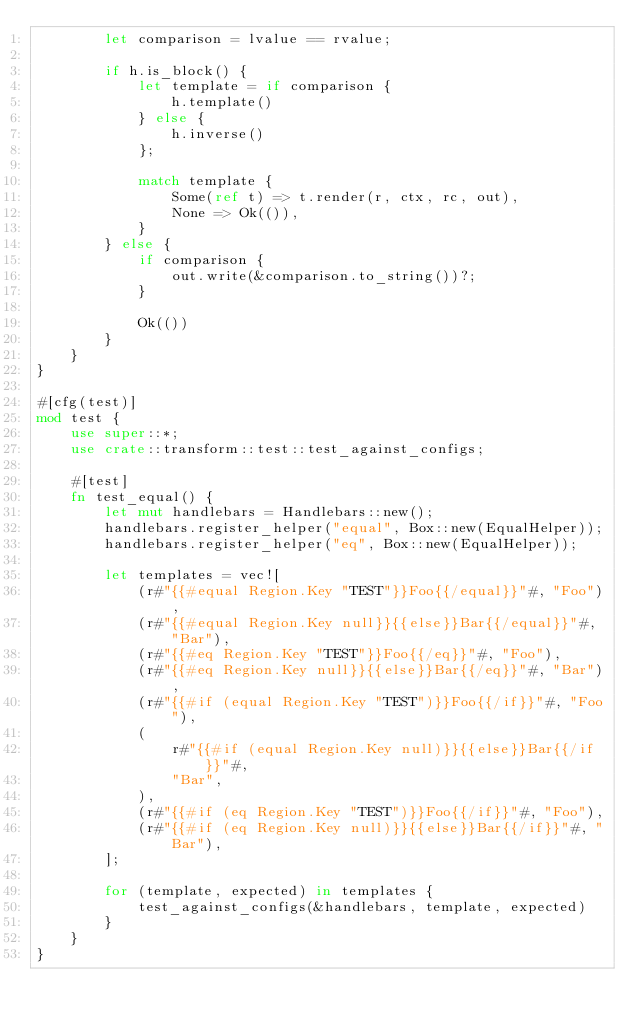Convert code to text. <code><loc_0><loc_0><loc_500><loc_500><_Rust_>        let comparison = lvalue == rvalue;

        if h.is_block() {
            let template = if comparison {
                h.template()
            } else {
                h.inverse()
            };

            match template {
                Some(ref t) => t.render(r, ctx, rc, out),
                None => Ok(()),
            }
        } else {
            if comparison {
                out.write(&comparison.to_string())?;
            }

            Ok(())
        }
    }
}

#[cfg(test)]
mod test {
    use super::*;
    use crate::transform::test::test_against_configs;

    #[test]
    fn test_equal() {
        let mut handlebars = Handlebars::new();
        handlebars.register_helper("equal", Box::new(EqualHelper));
        handlebars.register_helper("eq", Box::new(EqualHelper));

        let templates = vec![
            (r#"{{#equal Region.Key "TEST"}}Foo{{/equal}}"#, "Foo"),
            (r#"{{#equal Region.Key null}}{{else}}Bar{{/equal}}"#, "Bar"),
            (r#"{{#eq Region.Key "TEST"}}Foo{{/eq}}"#, "Foo"),
            (r#"{{#eq Region.Key null}}{{else}}Bar{{/eq}}"#, "Bar"),
            (r#"{{#if (equal Region.Key "TEST")}}Foo{{/if}}"#, "Foo"),
            (
                r#"{{#if (equal Region.Key null)}}{{else}}Bar{{/if}}"#,
                "Bar",
            ),
            (r#"{{#if (eq Region.Key "TEST")}}Foo{{/if}}"#, "Foo"),
            (r#"{{#if (eq Region.Key null)}}{{else}}Bar{{/if}}"#, "Bar"),
        ];

        for (template, expected) in templates {
            test_against_configs(&handlebars, template, expected)
        }
    }
}
</code> 